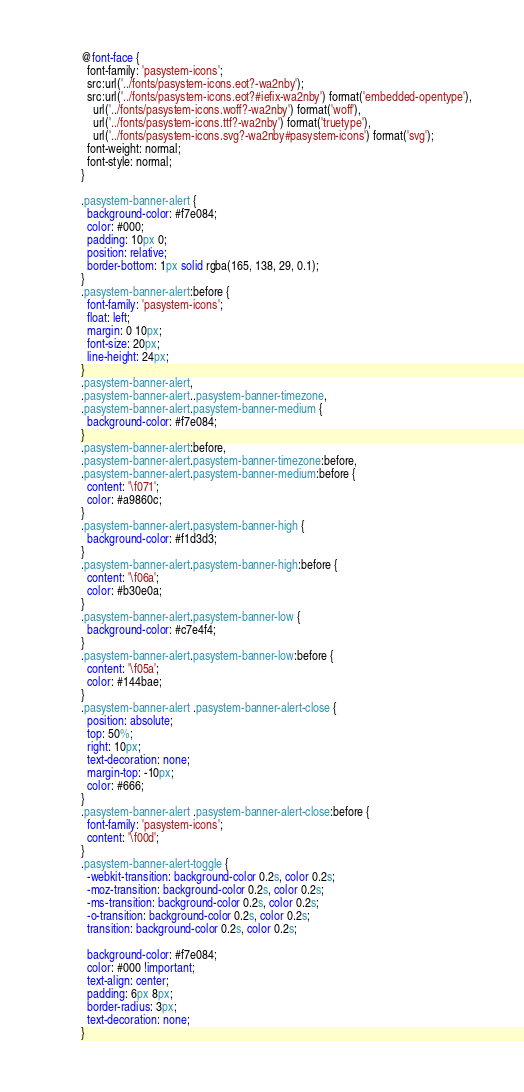Convert code to text. <code><loc_0><loc_0><loc_500><loc_500><_CSS_>@font-face {
  font-family: 'pasystem-icons';
  src:url('../fonts/pasystem-icons.eot?-wa2nby');
  src:url('../fonts/pasystem-icons.eot?#iefix-wa2nby') format('embedded-opentype'),
    url('../fonts/pasystem-icons.woff?-wa2nby') format('woff'),
    url('../fonts/pasystem-icons.ttf?-wa2nby') format('truetype'),
    url('../fonts/pasystem-icons.svg?-wa2nby#pasystem-icons') format('svg');
  font-weight: normal;
  font-style: normal;
}

.pasystem-banner-alert {
  background-color: #f7e084;
  color: #000;
  padding: 10px 0;
  position: relative;
  border-bottom: 1px solid rgba(165, 138, 29, 0.1);
}
.pasystem-banner-alert:before {
  font-family: 'pasystem-icons';
  float: left;
  margin: 0 10px;
  font-size: 20px;
  line-height: 24px;
}
.pasystem-banner-alert,
.pasystem-banner-alert..pasystem-banner-timezone,
.pasystem-banner-alert.pasystem-banner-medium {
  background-color: #f7e084;
}
.pasystem-banner-alert:before,
.pasystem-banner-alert.pasystem-banner-timezone:before,
.pasystem-banner-alert.pasystem-banner-medium:before {
  content: '\f071';
  color: #a9860c;
}
.pasystem-banner-alert.pasystem-banner-high {
  background-color: #f1d3d3;
}
.pasystem-banner-alert.pasystem-banner-high:before {
  content: '\f06a';
  color: #b30e0a;
}
.pasystem-banner-alert.pasystem-banner-low {
  background-color: #c7e4f4;
}
.pasystem-banner-alert.pasystem-banner-low:before {
  content: '\f05a';
  color: #144bae;
}
.pasystem-banner-alert .pasystem-banner-alert-close {
  position: absolute;
  top: 50%;
  right: 10px;
  text-decoration: none;
  margin-top: -10px;
  color: #666;
}
.pasystem-banner-alert .pasystem-banner-alert-close:before {
  font-family: 'pasystem-icons';
  content: '\f00d';
}
.pasystem-banner-alert-toggle {
  -webkit-transition: background-color 0.2s, color 0.2s;
  -moz-transition: background-color 0.2s, color 0.2s;
  -ms-transition: background-color 0.2s, color 0.2s;
  -o-transition: background-color 0.2s, color 0.2s;
  transition: background-color 0.2s, color 0.2s;

  background-color: #f7e084;
  color: #000 !important;
  text-align: center;
  padding: 6px 8px;
  border-radius: 3px;
  text-decoration: none;
}</code> 